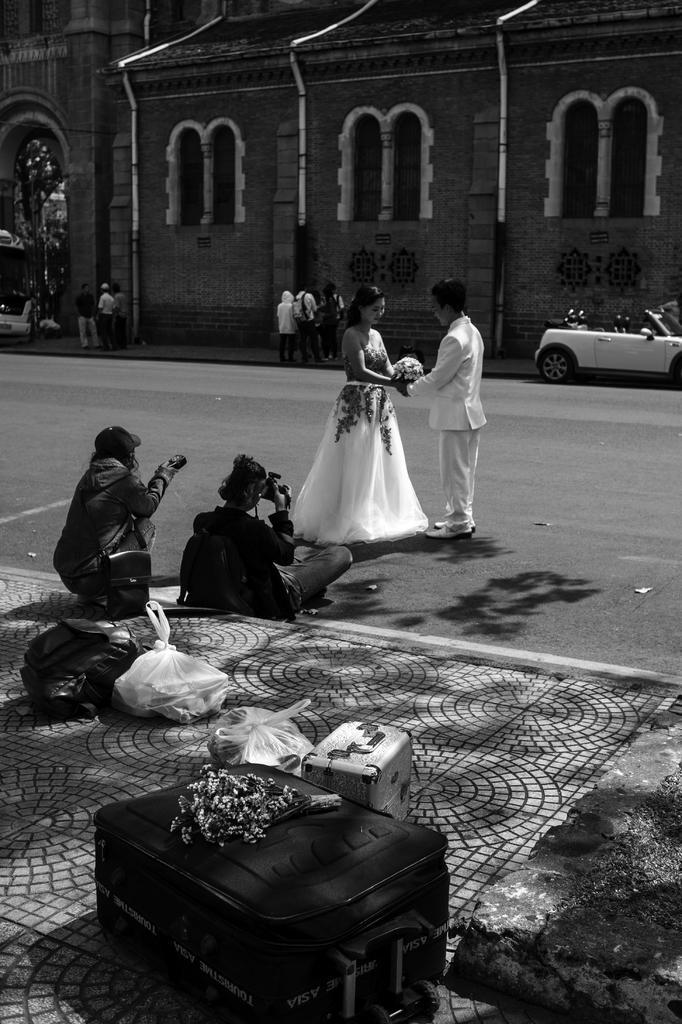How would you summarize this image in a sentence or two? This is a black and white image and in the center of the image, we can see a bride and a bridegroom holding an object. In the background, there are buildings, poles and we can see some vehicles on the road and in the front, we can see people and some are holding cameras and there are some covers, packets and bags on the sidewalk. 